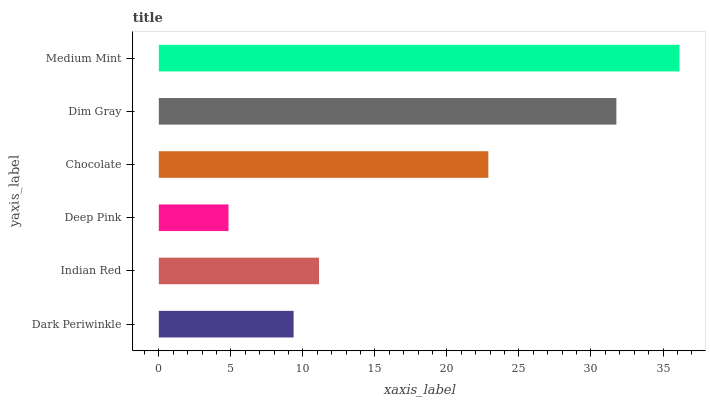Is Deep Pink the minimum?
Answer yes or no. Yes. Is Medium Mint the maximum?
Answer yes or no. Yes. Is Indian Red the minimum?
Answer yes or no. No. Is Indian Red the maximum?
Answer yes or no. No. Is Indian Red greater than Dark Periwinkle?
Answer yes or no. Yes. Is Dark Periwinkle less than Indian Red?
Answer yes or no. Yes. Is Dark Periwinkle greater than Indian Red?
Answer yes or no. No. Is Indian Red less than Dark Periwinkle?
Answer yes or no. No. Is Chocolate the high median?
Answer yes or no. Yes. Is Indian Red the low median?
Answer yes or no. Yes. Is Deep Pink the high median?
Answer yes or no. No. Is Medium Mint the low median?
Answer yes or no. No. 